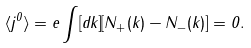<formula> <loc_0><loc_0><loc_500><loc_500>\langle j ^ { 0 } \rangle = e \int [ d { k } ] [ N _ { + } ( { k } ) - N _ { - } ( { k } ) ] = 0 .</formula> 